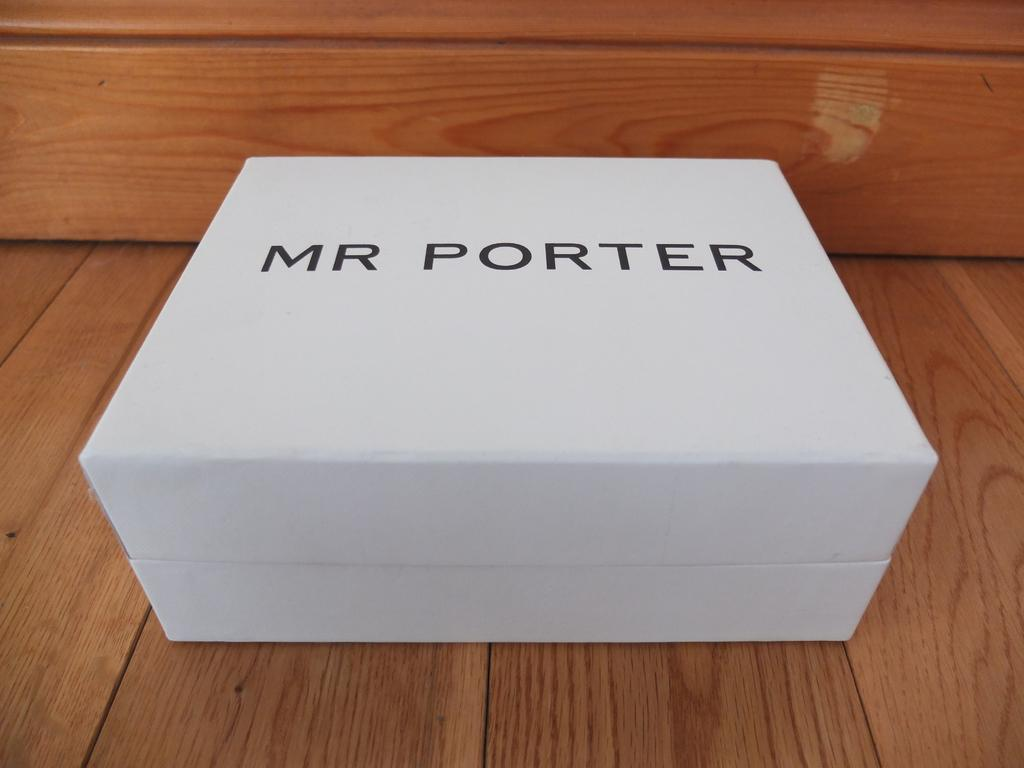<image>
Create a compact narrative representing the image presented. A white box with the name Mr Porter on the top. 